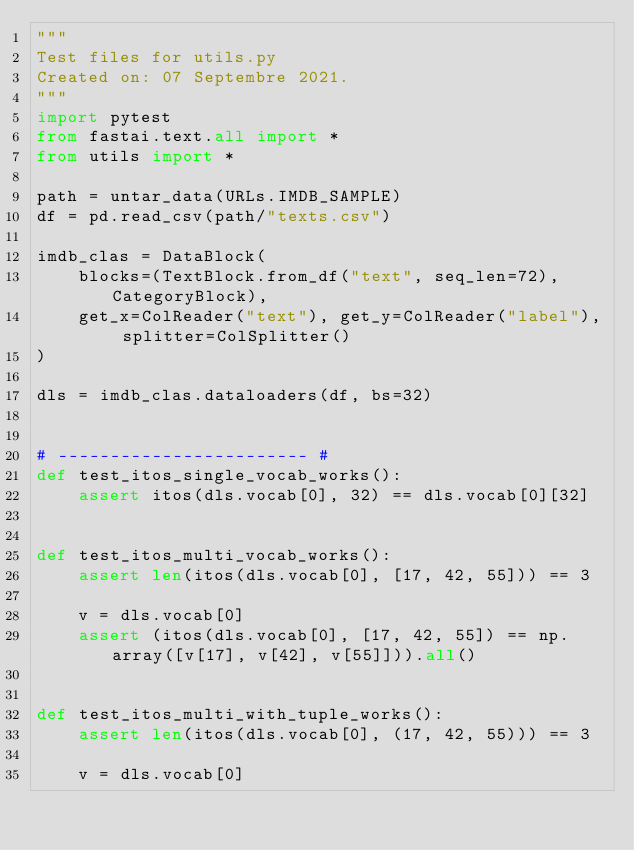<code> <loc_0><loc_0><loc_500><loc_500><_Python_>"""
Test files for utils.py
Created on: 07 Septembre 2021.
"""
import pytest
from fastai.text.all import *
from utils import *

path = untar_data(URLs.IMDB_SAMPLE)
df = pd.read_csv(path/"texts.csv")

imdb_clas = DataBlock(
    blocks=(TextBlock.from_df("text", seq_len=72), CategoryBlock),
    get_x=ColReader("text"), get_y=ColReader("label"), splitter=ColSplitter()
)

dls = imdb_clas.dataloaders(df, bs=32)


# ------------------------ #
def test_itos_single_vocab_works():
    assert itos(dls.vocab[0], 32) == dls.vocab[0][32]


def test_itos_multi_vocab_works():
    assert len(itos(dls.vocab[0], [17, 42, 55])) == 3

    v = dls.vocab[0]
    assert (itos(dls.vocab[0], [17, 42, 55]) == np.array([v[17], v[42], v[55]])).all()


def test_itos_multi_with_tuple_works(): 
    assert len(itos(dls.vocab[0], (17, 42, 55))) == 3

    v = dls.vocab[0]</code> 